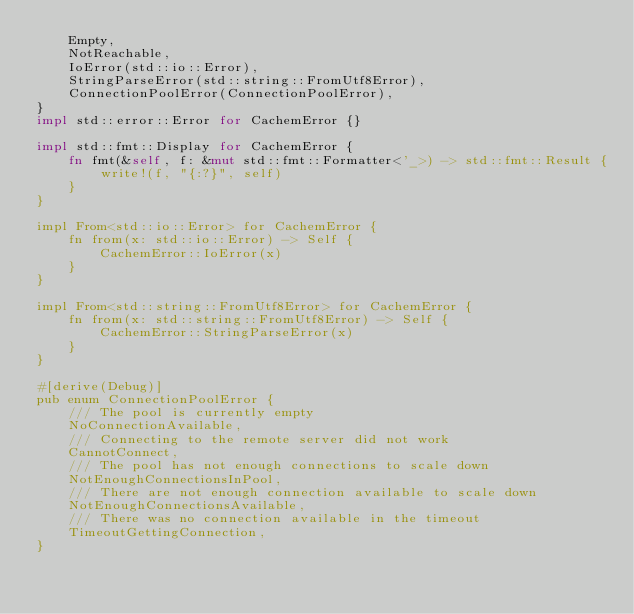<code> <loc_0><loc_0><loc_500><loc_500><_Rust_>    Empty,
    NotReachable,
    IoError(std::io::Error),
    StringParseError(std::string::FromUtf8Error),
    ConnectionPoolError(ConnectionPoolError),
}
impl std::error::Error for CachemError {}

impl std::fmt::Display for CachemError {
    fn fmt(&self, f: &mut std::fmt::Formatter<'_>) -> std::fmt::Result {
        write!(f, "{:?}", self) 
    }
}

impl From<std::io::Error> for CachemError {
    fn from(x: std::io::Error) -> Self {
        CachemError::IoError(x)
    }
}

impl From<std::string::FromUtf8Error> for CachemError {
    fn from(x: std::string::FromUtf8Error) -> Self {
        CachemError::StringParseError(x)
    }
}

#[derive(Debug)]
pub enum ConnectionPoolError {
    /// The pool is currently empty
    NoConnectionAvailable,
    /// Connecting to the remote server did not work
    CannotConnect,
    /// The pool has not enough connections to scale down
    NotEnoughConnectionsInPool,
    /// There are not enough connection available to scale down
    NotEnoughConnectionsAvailable,
    /// There was no connection available in the timeout
    TimeoutGettingConnection,
}
</code> 